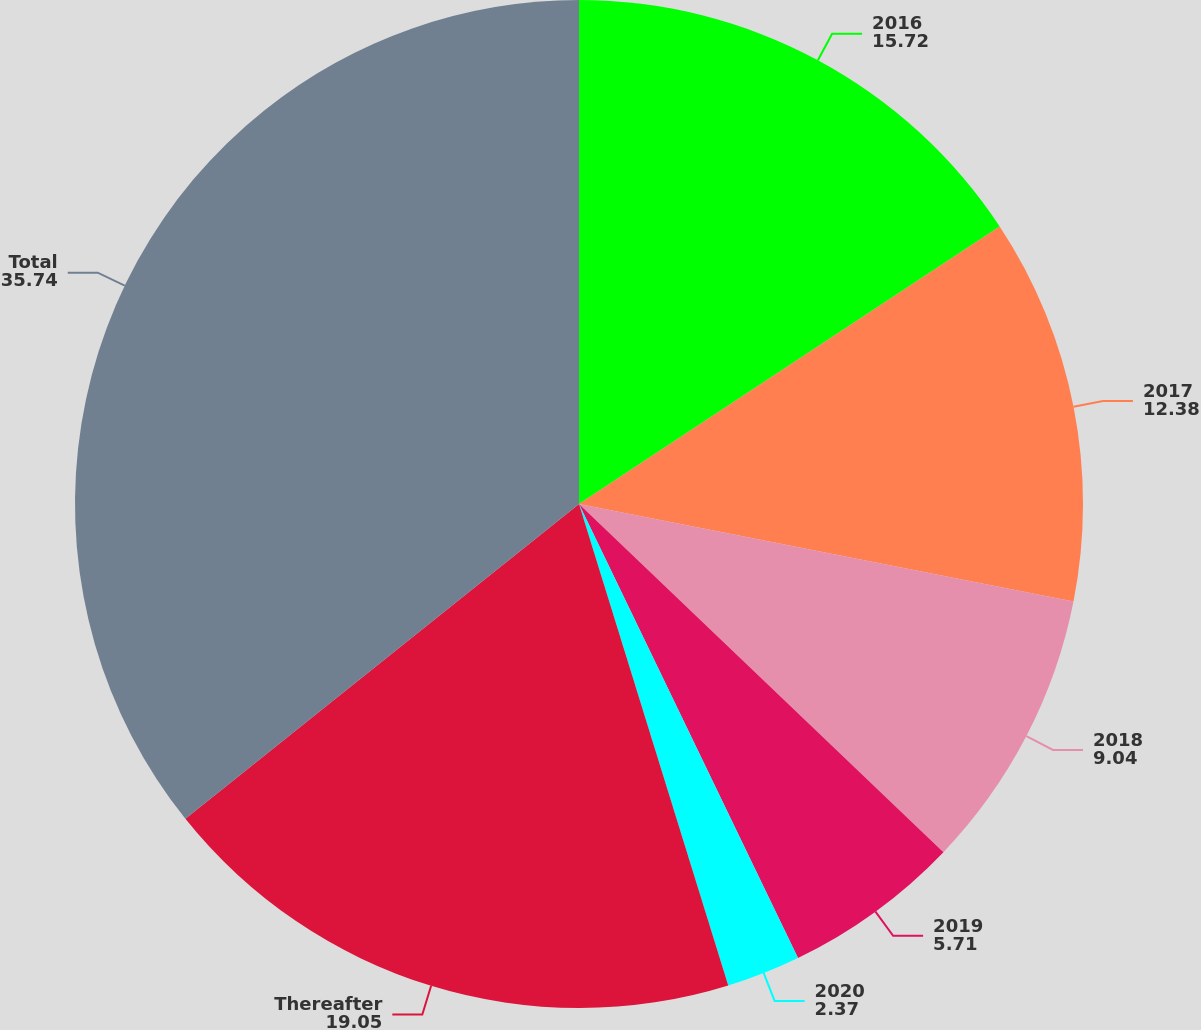Convert chart. <chart><loc_0><loc_0><loc_500><loc_500><pie_chart><fcel>2016<fcel>2017<fcel>2018<fcel>2019<fcel>2020<fcel>Thereafter<fcel>Total<nl><fcel>15.72%<fcel>12.38%<fcel>9.04%<fcel>5.71%<fcel>2.37%<fcel>19.05%<fcel>35.74%<nl></chart> 